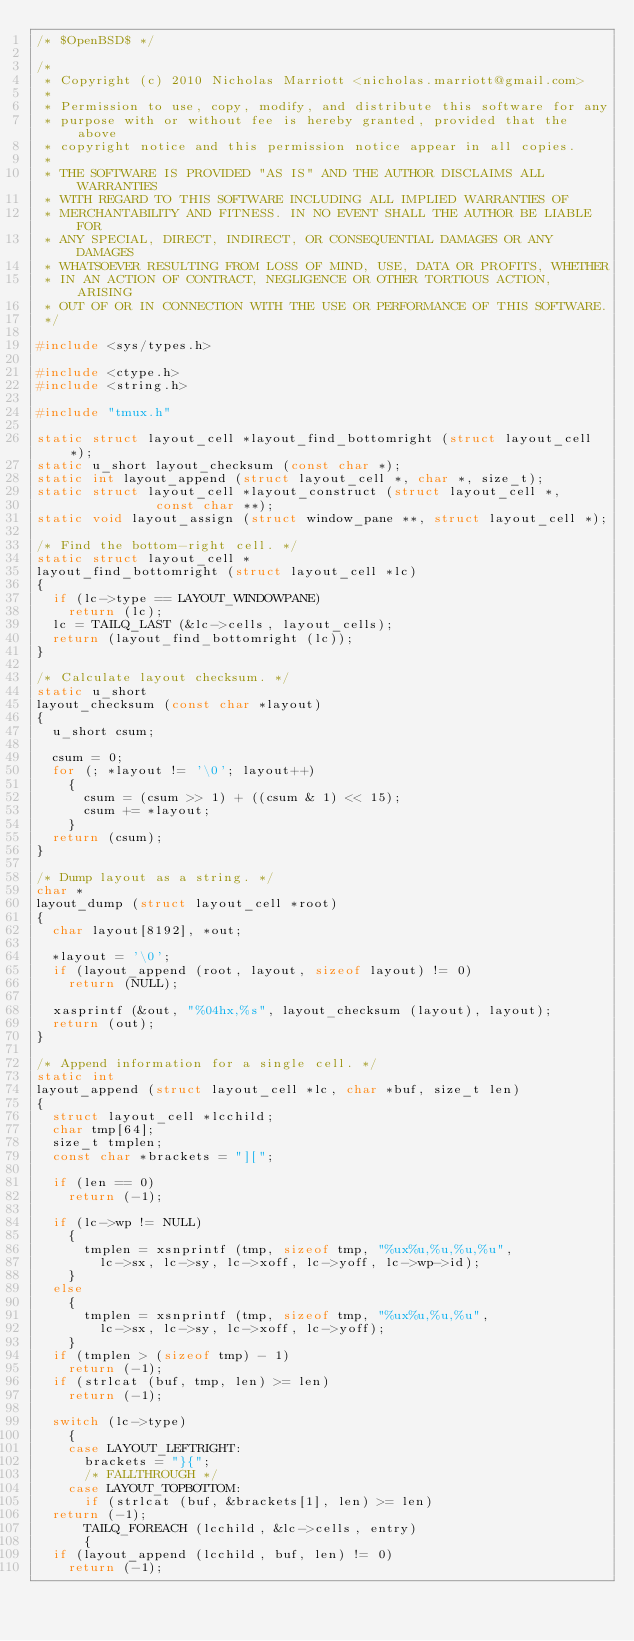Convert code to text. <code><loc_0><loc_0><loc_500><loc_500><_C_>/* $OpenBSD$ */

/*
 * Copyright (c) 2010 Nicholas Marriott <nicholas.marriott@gmail.com>
 *
 * Permission to use, copy, modify, and distribute this software for any
 * purpose with or without fee is hereby granted, provided that the above
 * copyright notice and this permission notice appear in all copies.
 *
 * THE SOFTWARE IS PROVIDED "AS IS" AND THE AUTHOR DISCLAIMS ALL WARRANTIES
 * WITH REGARD TO THIS SOFTWARE INCLUDING ALL IMPLIED WARRANTIES OF
 * MERCHANTABILITY AND FITNESS. IN NO EVENT SHALL THE AUTHOR BE LIABLE FOR
 * ANY SPECIAL, DIRECT, INDIRECT, OR CONSEQUENTIAL DAMAGES OR ANY DAMAGES
 * WHATSOEVER RESULTING FROM LOSS OF MIND, USE, DATA OR PROFITS, WHETHER
 * IN AN ACTION OF CONTRACT, NEGLIGENCE OR OTHER TORTIOUS ACTION, ARISING
 * OUT OF OR IN CONNECTION WITH THE USE OR PERFORMANCE OF THIS SOFTWARE.
 */

#include <sys/types.h>

#include <ctype.h>
#include <string.h>

#include "tmux.h"

static struct layout_cell *layout_find_bottomright (struct layout_cell *);
static u_short layout_checksum (const char *);
static int layout_append (struct layout_cell *, char *, size_t);
static struct layout_cell *layout_construct (struct layout_cell *,
					     const char **);
static void layout_assign (struct window_pane **, struct layout_cell *);

/* Find the bottom-right cell. */
static struct layout_cell *
layout_find_bottomright (struct layout_cell *lc)
{
  if (lc->type == LAYOUT_WINDOWPANE)
    return (lc);
  lc = TAILQ_LAST (&lc->cells, layout_cells);
  return (layout_find_bottomright (lc));
}

/* Calculate layout checksum. */
static u_short
layout_checksum (const char *layout)
{
  u_short csum;

  csum = 0;
  for (; *layout != '\0'; layout++)
    {
      csum = (csum >> 1) + ((csum & 1) << 15);
      csum += *layout;
    }
  return (csum);
}

/* Dump layout as a string. */
char *
layout_dump (struct layout_cell *root)
{
  char layout[8192], *out;

  *layout = '\0';
  if (layout_append (root, layout, sizeof layout) != 0)
    return (NULL);

  xasprintf (&out, "%04hx,%s", layout_checksum (layout), layout);
  return (out);
}

/* Append information for a single cell. */
static int
layout_append (struct layout_cell *lc, char *buf, size_t len)
{
  struct layout_cell *lcchild;
  char tmp[64];
  size_t tmplen;
  const char *brackets = "][";

  if (len == 0)
    return (-1);

  if (lc->wp != NULL)
    {
      tmplen = xsnprintf (tmp, sizeof tmp, "%ux%u,%u,%u,%u",
			  lc->sx, lc->sy, lc->xoff, lc->yoff, lc->wp->id);
    }
  else
    {
      tmplen = xsnprintf (tmp, sizeof tmp, "%ux%u,%u,%u",
			  lc->sx, lc->sy, lc->xoff, lc->yoff);
    }
  if (tmplen > (sizeof tmp) - 1)
    return (-1);
  if (strlcat (buf, tmp, len) >= len)
    return (-1);

  switch (lc->type)
    {
    case LAYOUT_LEFTRIGHT:
      brackets = "}{";
      /* FALLTHROUGH */
    case LAYOUT_TOPBOTTOM:
      if (strlcat (buf, &brackets[1], len) >= len)
	return (-1);
      TAILQ_FOREACH (lcchild, &lc->cells, entry)
      {
	if (layout_append (lcchild, buf, len) != 0)
	  return (-1);</code> 